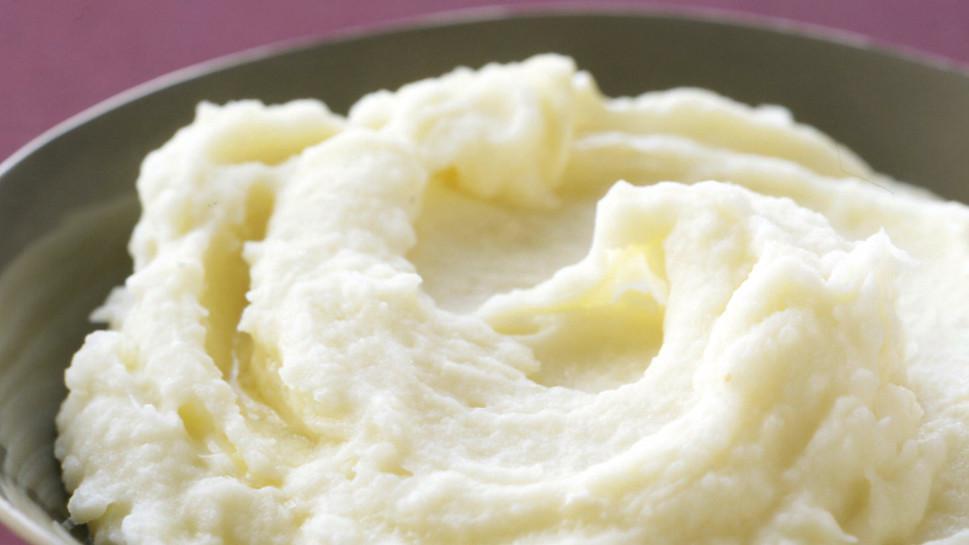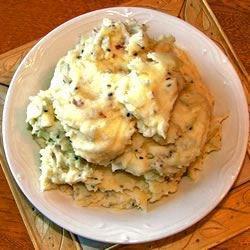The first image is the image on the left, the second image is the image on the right. Evaluate the accuracy of this statement regarding the images: "Large flakes of green garnish adorn the potatoes in the image on left.". Is it true? Answer yes or no. No. The first image is the image on the left, the second image is the image on the right. Assess this claim about the two images: "One image shows food in a white bowl, and the other does not.". Correct or not? Answer yes or no. Yes. 